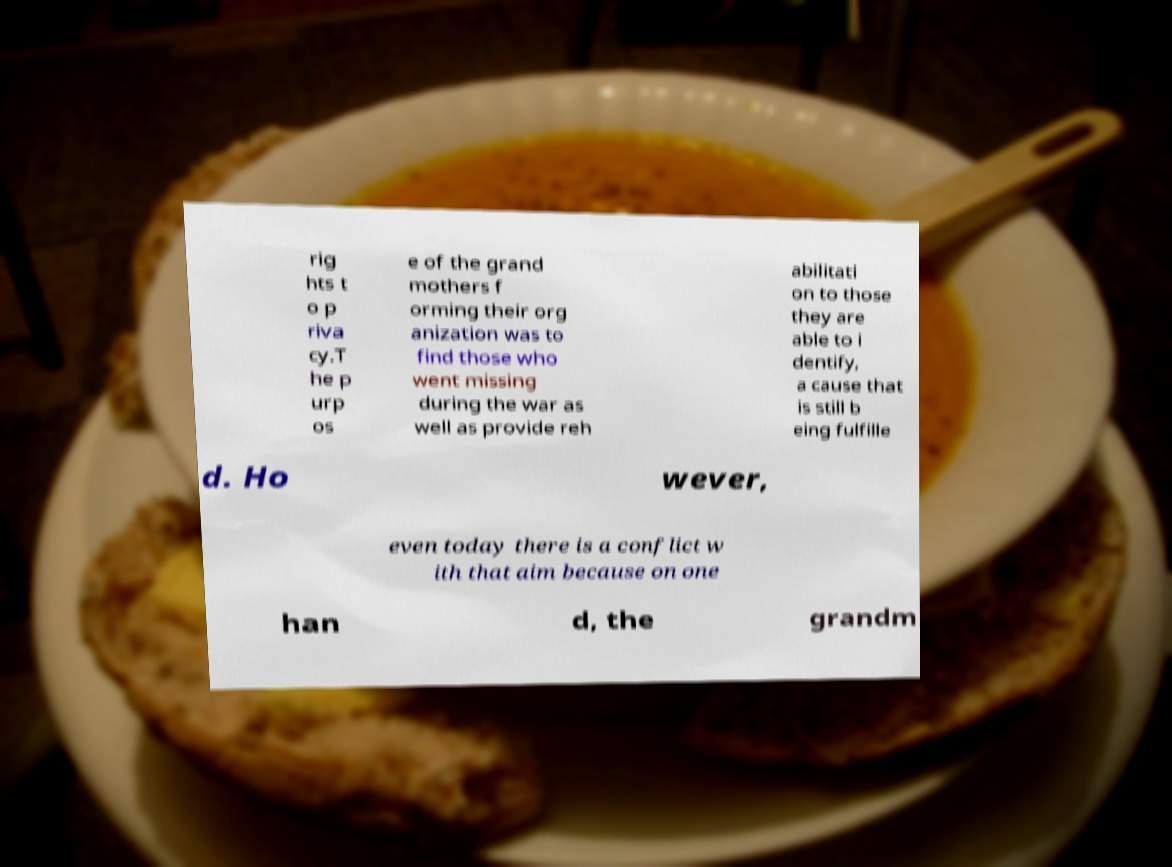What messages or text are displayed in this image? I need them in a readable, typed format. rig hts t o p riva cy.T he p urp os e of the grand mothers f orming their org anization was to find those who went missing during the war as well as provide reh abilitati on to those they are able to i dentify, a cause that is still b eing fulfille d. Ho wever, even today there is a conflict w ith that aim because on one han d, the grandm 